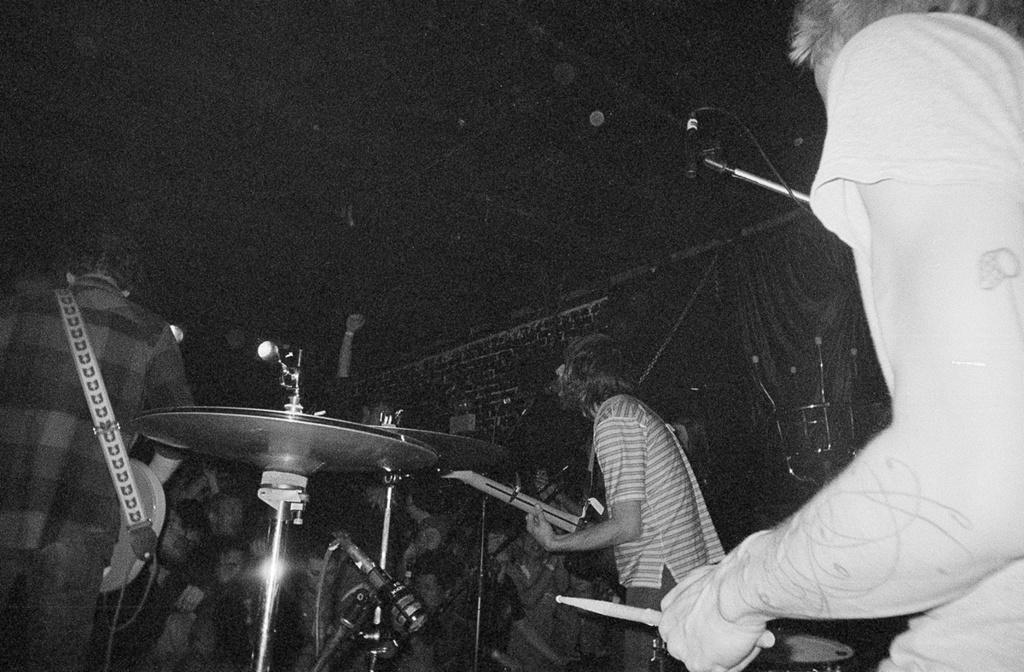Describe this image in one or two sentences. As we can see in the image there are few people playing different types of musical instruments. 